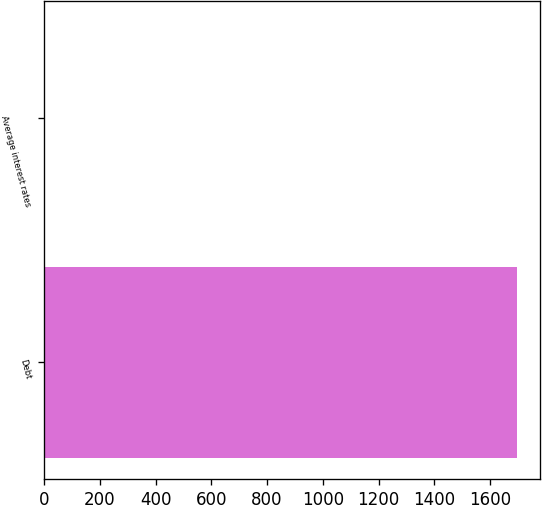Convert chart to OTSL. <chart><loc_0><loc_0><loc_500><loc_500><bar_chart><fcel>Debt<fcel>Average interest rates<nl><fcel>1696<fcel>4.9<nl></chart> 